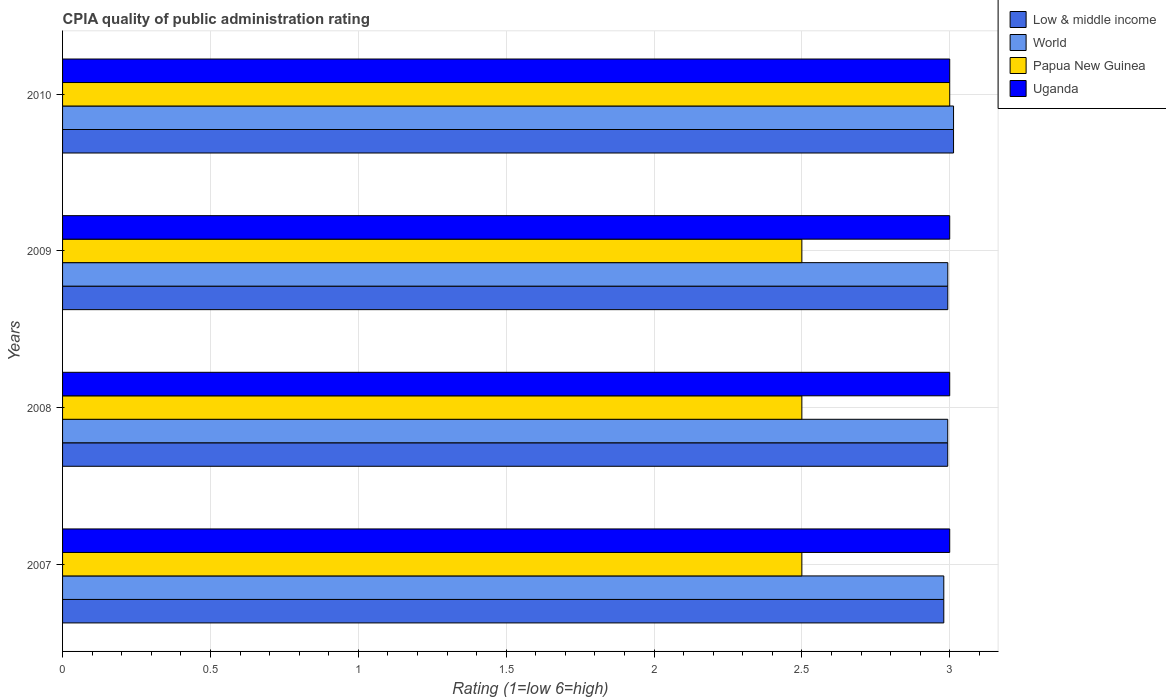How many groups of bars are there?
Provide a short and direct response. 4. In how many cases, is the number of bars for a given year not equal to the number of legend labels?
Keep it short and to the point. 0. What is the CPIA rating in Uganda in 2010?
Provide a succinct answer. 3. Across all years, what is the maximum CPIA rating in Uganda?
Make the answer very short. 3. Across all years, what is the minimum CPIA rating in World?
Offer a terse response. 2.98. In which year was the CPIA rating in Papua New Guinea maximum?
Your response must be concise. 2010. In which year was the CPIA rating in Uganda minimum?
Offer a very short reply. 2007. What is the total CPIA rating in Uganda in the graph?
Make the answer very short. 12. What is the difference between the CPIA rating in Uganda in 2007 and that in 2009?
Offer a terse response. 0. What is the difference between the CPIA rating in World in 2010 and the CPIA rating in Low & middle income in 2009?
Your answer should be very brief. 0.02. In the year 2009, what is the difference between the CPIA rating in Uganda and CPIA rating in Papua New Guinea?
Offer a terse response. 0.5. What is the ratio of the CPIA rating in Low & middle income in 2007 to that in 2009?
Keep it short and to the point. 1. Is the CPIA rating in Papua New Guinea in 2008 less than that in 2010?
Ensure brevity in your answer.  Yes. What is the difference between the highest and the second highest CPIA rating in World?
Provide a short and direct response. 0.02. What is the difference between the highest and the lowest CPIA rating in Papua New Guinea?
Your answer should be very brief. 0.5. In how many years, is the CPIA rating in Low & middle income greater than the average CPIA rating in Low & middle income taken over all years?
Your answer should be very brief. 1. Is the sum of the CPIA rating in Uganda in 2009 and 2010 greater than the maximum CPIA rating in Papua New Guinea across all years?
Offer a terse response. Yes. What does the 1st bar from the top in 2010 represents?
Give a very brief answer. Uganda. What does the 3rd bar from the bottom in 2009 represents?
Your answer should be compact. Papua New Guinea. How many bars are there?
Give a very brief answer. 16. What is the difference between two consecutive major ticks on the X-axis?
Ensure brevity in your answer.  0.5. Are the values on the major ticks of X-axis written in scientific E-notation?
Your answer should be compact. No. How are the legend labels stacked?
Offer a terse response. Vertical. What is the title of the graph?
Offer a terse response. CPIA quality of public administration rating. Does "Andorra" appear as one of the legend labels in the graph?
Ensure brevity in your answer.  No. What is the label or title of the X-axis?
Provide a succinct answer. Rating (1=low 6=high). What is the label or title of the Y-axis?
Give a very brief answer. Years. What is the Rating (1=low 6=high) of Low & middle income in 2007?
Your response must be concise. 2.98. What is the Rating (1=low 6=high) in World in 2007?
Offer a terse response. 2.98. What is the Rating (1=low 6=high) of Papua New Guinea in 2007?
Provide a short and direct response. 2.5. What is the Rating (1=low 6=high) of Uganda in 2007?
Your answer should be compact. 3. What is the Rating (1=low 6=high) of Low & middle income in 2008?
Keep it short and to the point. 2.99. What is the Rating (1=low 6=high) of World in 2008?
Your answer should be very brief. 2.99. What is the Rating (1=low 6=high) of Papua New Guinea in 2008?
Your response must be concise. 2.5. What is the Rating (1=low 6=high) of Low & middle income in 2009?
Your answer should be very brief. 2.99. What is the Rating (1=low 6=high) in World in 2009?
Provide a short and direct response. 2.99. What is the Rating (1=low 6=high) in Low & middle income in 2010?
Provide a succinct answer. 3.01. What is the Rating (1=low 6=high) in World in 2010?
Your answer should be very brief. 3.01. What is the Rating (1=low 6=high) of Papua New Guinea in 2010?
Your response must be concise. 3. What is the Rating (1=low 6=high) of Uganda in 2010?
Your answer should be very brief. 3. Across all years, what is the maximum Rating (1=low 6=high) in Low & middle income?
Your response must be concise. 3.01. Across all years, what is the maximum Rating (1=low 6=high) in World?
Offer a terse response. 3.01. Across all years, what is the maximum Rating (1=low 6=high) of Papua New Guinea?
Provide a short and direct response. 3. Across all years, what is the minimum Rating (1=low 6=high) in Low & middle income?
Ensure brevity in your answer.  2.98. Across all years, what is the minimum Rating (1=low 6=high) of World?
Your answer should be very brief. 2.98. Across all years, what is the minimum Rating (1=low 6=high) of Uganda?
Make the answer very short. 3. What is the total Rating (1=low 6=high) in Low & middle income in the graph?
Your response must be concise. 11.98. What is the total Rating (1=low 6=high) of World in the graph?
Keep it short and to the point. 11.98. What is the total Rating (1=low 6=high) of Papua New Guinea in the graph?
Provide a short and direct response. 10.5. What is the total Rating (1=low 6=high) of Uganda in the graph?
Make the answer very short. 12. What is the difference between the Rating (1=low 6=high) in Low & middle income in 2007 and that in 2008?
Give a very brief answer. -0.01. What is the difference between the Rating (1=low 6=high) in World in 2007 and that in 2008?
Make the answer very short. -0.01. What is the difference between the Rating (1=low 6=high) in Papua New Guinea in 2007 and that in 2008?
Provide a short and direct response. 0. What is the difference between the Rating (1=low 6=high) in Low & middle income in 2007 and that in 2009?
Ensure brevity in your answer.  -0.01. What is the difference between the Rating (1=low 6=high) in World in 2007 and that in 2009?
Provide a succinct answer. -0.01. What is the difference between the Rating (1=low 6=high) in Papua New Guinea in 2007 and that in 2009?
Offer a terse response. 0. What is the difference between the Rating (1=low 6=high) in Uganda in 2007 and that in 2009?
Provide a short and direct response. 0. What is the difference between the Rating (1=low 6=high) in Low & middle income in 2007 and that in 2010?
Make the answer very short. -0.03. What is the difference between the Rating (1=low 6=high) of World in 2007 and that in 2010?
Make the answer very short. -0.03. What is the difference between the Rating (1=low 6=high) of Papua New Guinea in 2007 and that in 2010?
Offer a very short reply. -0.5. What is the difference between the Rating (1=low 6=high) in Low & middle income in 2008 and that in 2009?
Make the answer very short. -0. What is the difference between the Rating (1=low 6=high) in World in 2008 and that in 2009?
Your response must be concise. -0. What is the difference between the Rating (1=low 6=high) in Papua New Guinea in 2008 and that in 2009?
Your answer should be compact. 0. What is the difference between the Rating (1=low 6=high) in Low & middle income in 2008 and that in 2010?
Give a very brief answer. -0.02. What is the difference between the Rating (1=low 6=high) of World in 2008 and that in 2010?
Your answer should be very brief. -0.02. What is the difference between the Rating (1=low 6=high) of Papua New Guinea in 2008 and that in 2010?
Give a very brief answer. -0.5. What is the difference between the Rating (1=low 6=high) in Uganda in 2008 and that in 2010?
Your answer should be very brief. 0. What is the difference between the Rating (1=low 6=high) of Low & middle income in 2009 and that in 2010?
Your answer should be very brief. -0.02. What is the difference between the Rating (1=low 6=high) of World in 2009 and that in 2010?
Give a very brief answer. -0.02. What is the difference between the Rating (1=low 6=high) of Papua New Guinea in 2009 and that in 2010?
Offer a very short reply. -0.5. What is the difference between the Rating (1=low 6=high) in Low & middle income in 2007 and the Rating (1=low 6=high) in World in 2008?
Your answer should be very brief. -0.01. What is the difference between the Rating (1=low 6=high) in Low & middle income in 2007 and the Rating (1=low 6=high) in Papua New Guinea in 2008?
Offer a very short reply. 0.48. What is the difference between the Rating (1=low 6=high) of Low & middle income in 2007 and the Rating (1=low 6=high) of Uganda in 2008?
Your response must be concise. -0.02. What is the difference between the Rating (1=low 6=high) of World in 2007 and the Rating (1=low 6=high) of Papua New Guinea in 2008?
Your response must be concise. 0.48. What is the difference between the Rating (1=low 6=high) in World in 2007 and the Rating (1=low 6=high) in Uganda in 2008?
Offer a terse response. -0.02. What is the difference between the Rating (1=low 6=high) of Low & middle income in 2007 and the Rating (1=low 6=high) of World in 2009?
Offer a very short reply. -0.01. What is the difference between the Rating (1=low 6=high) in Low & middle income in 2007 and the Rating (1=low 6=high) in Papua New Guinea in 2009?
Provide a short and direct response. 0.48. What is the difference between the Rating (1=low 6=high) of Low & middle income in 2007 and the Rating (1=low 6=high) of Uganda in 2009?
Provide a short and direct response. -0.02. What is the difference between the Rating (1=low 6=high) in World in 2007 and the Rating (1=low 6=high) in Papua New Guinea in 2009?
Offer a terse response. 0.48. What is the difference between the Rating (1=low 6=high) in World in 2007 and the Rating (1=low 6=high) in Uganda in 2009?
Your response must be concise. -0.02. What is the difference between the Rating (1=low 6=high) of Low & middle income in 2007 and the Rating (1=low 6=high) of World in 2010?
Provide a succinct answer. -0.03. What is the difference between the Rating (1=low 6=high) of Low & middle income in 2007 and the Rating (1=low 6=high) of Papua New Guinea in 2010?
Give a very brief answer. -0.02. What is the difference between the Rating (1=low 6=high) of Low & middle income in 2007 and the Rating (1=low 6=high) of Uganda in 2010?
Provide a succinct answer. -0.02. What is the difference between the Rating (1=low 6=high) of World in 2007 and the Rating (1=low 6=high) of Papua New Guinea in 2010?
Your answer should be very brief. -0.02. What is the difference between the Rating (1=low 6=high) of World in 2007 and the Rating (1=low 6=high) of Uganda in 2010?
Offer a very short reply. -0.02. What is the difference between the Rating (1=low 6=high) of Low & middle income in 2008 and the Rating (1=low 6=high) of World in 2009?
Provide a short and direct response. -0. What is the difference between the Rating (1=low 6=high) of Low & middle income in 2008 and the Rating (1=low 6=high) of Papua New Guinea in 2009?
Provide a succinct answer. 0.49. What is the difference between the Rating (1=low 6=high) in Low & middle income in 2008 and the Rating (1=low 6=high) in Uganda in 2009?
Give a very brief answer. -0.01. What is the difference between the Rating (1=low 6=high) in World in 2008 and the Rating (1=low 6=high) in Papua New Guinea in 2009?
Your response must be concise. 0.49. What is the difference between the Rating (1=low 6=high) of World in 2008 and the Rating (1=low 6=high) of Uganda in 2009?
Keep it short and to the point. -0.01. What is the difference between the Rating (1=low 6=high) of Papua New Guinea in 2008 and the Rating (1=low 6=high) of Uganda in 2009?
Provide a short and direct response. -0.5. What is the difference between the Rating (1=low 6=high) of Low & middle income in 2008 and the Rating (1=low 6=high) of World in 2010?
Ensure brevity in your answer.  -0.02. What is the difference between the Rating (1=low 6=high) of Low & middle income in 2008 and the Rating (1=low 6=high) of Papua New Guinea in 2010?
Offer a terse response. -0.01. What is the difference between the Rating (1=low 6=high) of Low & middle income in 2008 and the Rating (1=low 6=high) of Uganda in 2010?
Keep it short and to the point. -0.01. What is the difference between the Rating (1=low 6=high) in World in 2008 and the Rating (1=low 6=high) in Papua New Guinea in 2010?
Your answer should be compact. -0.01. What is the difference between the Rating (1=low 6=high) of World in 2008 and the Rating (1=low 6=high) of Uganda in 2010?
Your answer should be very brief. -0.01. What is the difference between the Rating (1=low 6=high) of Low & middle income in 2009 and the Rating (1=low 6=high) of World in 2010?
Offer a very short reply. -0.02. What is the difference between the Rating (1=low 6=high) of Low & middle income in 2009 and the Rating (1=low 6=high) of Papua New Guinea in 2010?
Offer a terse response. -0.01. What is the difference between the Rating (1=low 6=high) in Low & middle income in 2009 and the Rating (1=low 6=high) in Uganda in 2010?
Provide a short and direct response. -0.01. What is the difference between the Rating (1=low 6=high) in World in 2009 and the Rating (1=low 6=high) in Papua New Guinea in 2010?
Your answer should be compact. -0.01. What is the difference between the Rating (1=low 6=high) of World in 2009 and the Rating (1=low 6=high) of Uganda in 2010?
Provide a short and direct response. -0.01. What is the difference between the Rating (1=low 6=high) of Papua New Guinea in 2009 and the Rating (1=low 6=high) of Uganda in 2010?
Provide a succinct answer. -0.5. What is the average Rating (1=low 6=high) in Low & middle income per year?
Offer a very short reply. 3. What is the average Rating (1=low 6=high) in World per year?
Your answer should be very brief. 3. What is the average Rating (1=low 6=high) of Papua New Guinea per year?
Your answer should be compact. 2.62. In the year 2007, what is the difference between the Rating (1=low 6=high) of Low & middle income and Rating (1=low 6=high) of Papua New Guinea?
Keep it short and to the point. 0.48. In the year 2007, what is the difference between the Rating (1=low 6=high) of Low & middle income and Rating (1=low 6=high) of Uganda?
Offer a very short reply. -0.02. In the year 2007, what is the difference between the Rating (1=low 6=high) of World and Rating (1=low 6=high) of Papua New Guinea?
Make the answer very short. 0.48. In the year 2007, what is the difference between the Rating (1=low 6=high) of World and Rating (1=low 6=high) of Uganda?
Your answer should be compact. -0.02. In the year 2007, what is the difference between the Rating (1=low 6=high) of Papua New Guinea and Rating (1=low 6=high) of Uganda?
Ensure brevity in your answer.  -0.5. In the year 2008, what is the difference between the Rating (1=low 6=high) of Low & middle income and Rating (1=low 6=high) of World?
Provide a short and direct response. 0. In the year 2008, what is the difference between the Rating (1=low 6=high) in Low & middle income and Rating (1=low 6=high) in Papua New Guinea?
Ensure brevity in your answer.  0.49. In the year 2008, what is the difference between the Rating (1=low 6=high) of Low & middle income and Rating (1=low 6=high) of Uganda?
Your answer should be very brief. -0.01. In the year 2008, what is the difference between the Rating (1=low 6=high) of World and Rating (1=low 6=high) of Papua New Guinea?
Provide a succinct answer. 0.49. In the year 2008, what is the difference between the Rating (1=low 6=high) in World and Rating (1=low 6=high) in Uganda?
Your response must be concise. -0.01. In the year 2009, what is the difference between the Rating (1=low 6=high) of Low & middle income and Rating (1=low 6=high) of Papua New Guinea?
Your response must be concise. 0.49. In the year 2009, what is the difference between the Rating (1=low 6=high) of Low & middle income and Rating (1=low 6=high) of Uganda?
Keep it short and to the point. -0.01. In the year 2009, what is the difference between the Rating (1=low 6=high) of World and Rating (1=low 6=high) of Papua New Guinea?
Provide a succinct answer. 0.49. In the year 2009, what is the difference between the Rating (1=low 6=high) of World and Rating (1=low 6=high) of Uganda?
Your response must be concise. -0.01. In the year 2009, what is the difference between the Rating (1=low 6=high) of Papua New Guinea and Rating (1=low 6=high) of Uganda?
Ensure brevity in your answer.  -0.5. In the year 2010, what is the difference between the Rating (1=low 6=high) in Low & middle income and Rating (1=low 6=high) in World?
Offer a terse response. 0. In the year 2010, what is the difference between the Rating (1=low 6=high) in Low & middle income and Rating (1=low 6=high) in Papua New Guinea?
Provide a succinct answer. 0.01. In the year 2010, what is the difference between the Rating (1=low 6=high) in Low & middle income and Rating (1=low 6=high) in Uganda?
Provide a succinct answer. 0.01. In the year 2010, what is the difference between the Rating (1=low 6=high) in World and Rating (1=low 6=high) in Papua New Guinea?
Make the answer very short. 0.01. In the year 2010, what is the difference between the Rating (1=low 6=high) in World and Rating (1=low 6=high) in Uganda?
Your answer should be compact. 0.01. In the year 2010, what is the difference between the Rating (1=low 6=high) of Papua New Guinea and Rating (1=low 6=high) of Uganda?
Keep it short and to the point. 0. What is the ratio of the Rating (1=low 6=high) in World in 2007 to that in 2008?
Provide a short and direct response. 1. What is the ratio of the Rating (1=low 6=high) in Papua New Guinea in 2007 to that in 2008?
Provide a short and direct response. 1. What is the ratio of the Rating (1=low 6=high) of Uganda in 2007 to that in 2008?
Your answer should be very brief. 1. What is the ratio of the Rating (1=low 6=high) of Low & middle income in 2007 to that in 2009?
Make the answer very short. 1. What is the ratio of the Rating (1=low 6=high) in World in 2007 to that in 2009?
Your answer should be very brief. 1. What is the ratio of the Rating (1=low 6=high) of World in 2007 to that in 2010?
Your answer should be very brief. 0.99. What is the ratio of the Rating (1=low 6=high) in Uganda in 2007 to that in 2010?
Your response must be concise. 1. What is the ratio of the Rating (1=low 6=high) in Uganda in 2008 to that in 2009?
Your response must be concise. 1. What is the ratio of the Rating (1=low 6=high) in Low & middle income in 2009 to that in 2010?
Make the answer very short. 0.99. What is the ratio of the Rating (1=low 6=high) in Papua New Guinea in 2009 to that in 2010?
Ensure brevity in your answer.  0.83. What is the difference between the highest and the second highest Rating (1=low 6=high) of Low & middle income?
Provide a short and direct response. 0.02. What is the difference between the highest and the second highest Rating (1=low 6=high) of World?
Ensure brevity in your answer.  0.02. What is the difference between the highest and the second highest Rating (1=low 6=high) of Uganda?
Provide a succinct answer. 0. What is the difference between the highest and the lowest Rating (1=low 6=high) of Low & middle income?
Provide a succinct answer. 0.03. What is the difference between the highest and the lowest Rating (1=low 6=high) of World?
Provide a short and direct response. 0.03. What is the difference between the highest and the lowest Rating (1=low 6=high) of Papua New Guinea?
Ensure brevity in your answer.  0.5. What is the difference between the highest and the lowest Rating (1=low 6=high) in Uganda?
Ensure brevity in your answer.  0. 